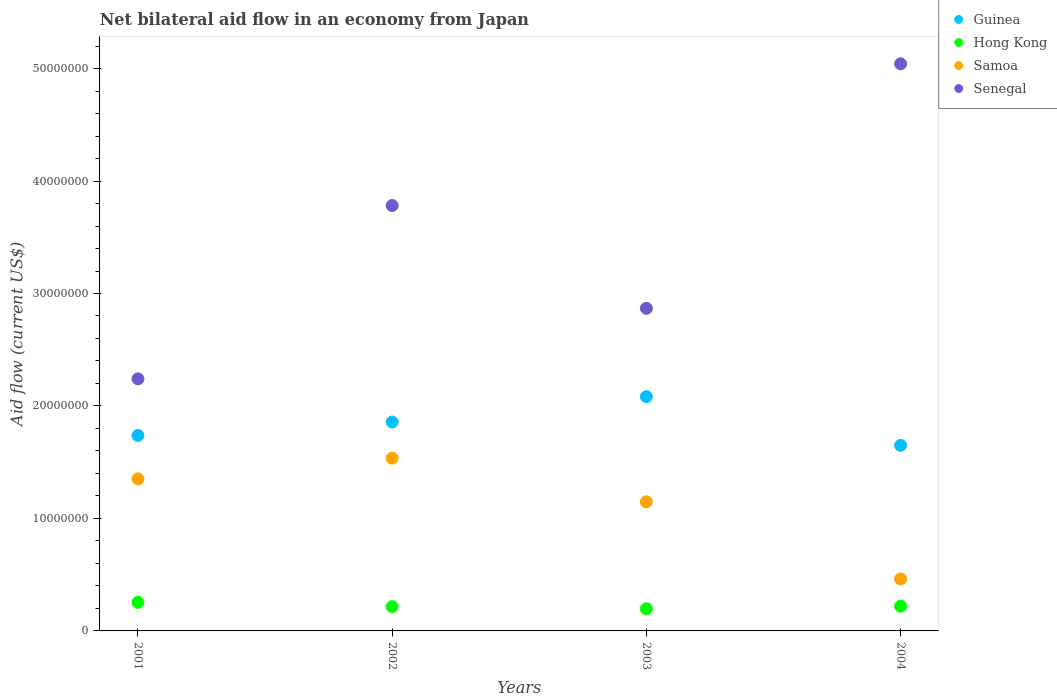What is the net bilateral aid flow in Senegal in 2003?
Provide a short and direct response. 2.87e+07. Across all years, what is the maximum net bilateral aid flow in Samoa?
Make the answer very short. 1.54e+07. Across all years, what is the minimum net bilateral aid flow in Guinea?
Offer a very short reply. 1.65e+07. In which year was the net bilateral aid flow in Hong Kong maximum?
Provide a succinct answer. 2001. What is the total net bilateral aid flow in Guinea in the graph?
Provide a succinct answer. 7.33e+07. What is the difference between the net bilateral aid flow in Hong Kong in 2001 and that in 2004?
Offer a very short reply. 3.40e+05. What is the difference between the net bilateral aid flow in Guinea in 2002 and the net bilateral aid flow in Hong Kong in 2003?
Ensure brevity in your answer.  1.66e+07. What is the average net bilateral aid flow in Senegal per year?
Ensure brevity in your answer.  3.48e+07. In the year 2004, what is the difference between the net bilateral aid flow in Senegal and net bilateral aid flow in Guinea?
Keep it short and to the point. 3.39e+07. In how many years, is the net bilateral aid flow in Samoa greater than 16000000 US$?
Offer a very short reply. 0. What is the ratio of the net bilateral aid flow in Samoa in 2002 to that in 2003?
Make the answer very short. 1.34. Is the difference between the net bilateral aid flow in Senegal in 2003 and 2004 greater than the difference between the net bilateral aid flow in Guinea in 2003 and 2004?
Offer a very short reply. No. What is the difference between the highest and the lowest net bilateral aid flow in Senegal?
Provide a short and direct response. 2.80e+07. Is the sum of the net bilateral aid flow in Hong Kong in 2002 and 2004 greater than the maximum net bilateral aid flow in Guinea across all years?
Make the answer very short. No. Is it the case that in every year, the sum of the net bilateral aid flow in Senegal and net bilateral aid flow in Guinea  is greater than the sum of net bilateral aid flow in Hong Kong and net bilateral aid flow in Samoa?
Your answer should be very brief. Yes. Is it the case that in every year, the sum of the net bilateral aid flow in Senegal and net bilateral aid flow in Samoa  is greater than the net bilateral aid flow in Hong Kong?
Offer a terse response. Yes. Does the net bilateral aid flow in Samoa monotonically increase over the years?
Provide a short and direct response. No. Is the net bilateral aid flow in Guinea strictly greater than the net bilateral aid flow in Samoa over the years?
Offer a terse response. Yes. Is the net bilateral aid flow in Senegal strictly less than the net bilateral aid flow in Samoa over the years?
Provide a succinct answer. No. How many dotlines are there?
Provide a succinct answer. 4. What is the difference between two consecutive major ticks on the Y-axis?
Your answer should be very brief. 1.00e+07. Are the values on the major ticks of Y-axis written in scientific E-notation?
Give a very brief answer. No. Does the graph contain any zero values?
Your response must be concise. No. Where does the legend appear in the graph?
Give a very brief answer. Top right. How many legend labels are there?
Your answer should be compact. 4. What is the title of the graph?
Your answer should be compact. Net bilateral aid flow in an economy from Japan. What is the label or title of the X-axis?
Keep it short and to the point. Years. What is the label or title of the Y-axis?
Provide a succinct answer. Aid flow (current US$). What is the Aid flow (current US$) of Guinea in 2001?
Your answer should be compact. 1.74e+07. What is the Aid flow (current US$) of Hong Kong in 2001?
Keep it short and to the point. 2.54e+06. What is the Aid flow (current US$) in Samoa in 2001?
Give a very brief answer. 1.35e+07. What is the Aid flow (current US$) of Senegal in 2001?
Make the answer very short. 2.24e+07. What is the Aid flow (current US$) of Guinea in 2002?
Your response must be concise. 1.86e+07. What is the Aid flow (current US$) of Hong Kong in 2002?
Offer a very short reply. 2.16e+06. What is the Aid flow (current US$) in Samoa in 2002?
Your answer should be compact. 1.54e+07. What is the Aid flow (current US$) of Senegal in 2002?
Provide a succinct answer. 3.78e+07. What is the Aid flow (current US$) in Guinea in 2003?
Provide a short and direct response. 2.08e+07. What is the Aid flow (current US$) of Hong Kong in 2003?
Your answer should be very brief. 1.97e+06. What is the Aid flow (current US$) in Samoa in 2003?
Ensure brevity in your answer.  1.15e+07. What is the Aid flow (current US$) in Senegal in 2003?
Provide a short and direct response. 2.87e+07. What is the Aid flow (current US$) of Guinea in 2004?
Provide a short and direct response. 1.65e+07. What is the Aid flow (current US$) in Hong Kong in 2004?
Provide a succinct answer. 2.20e+06. What is the Aid flow (current US$) in Samoa in 2004?
Your response must be concise. 4.62e+06. What is the Aid flow (current US$) in Senegal in 2004?
Provide a succinct answer. 5.04e+07. Across all years, what is the maximum Aid flow (current US$) in Guinea?
Your answer should be compact. 2.08e+07. Across all years, what is the maximum Aid flow (current US$) of Hong Kong?
Provide a succinct answer. 2.54e+06. Across all years, what is the maximum Aid flow (current US$) in Samoa?
Your answer should be very brief. 1.54e+07. Across all years, what is the maximum Aid flow (current US$) of Senegal?
Keep it short and to the point. 5.04e+07. Across all years, what is the minimum Aid flow (current US$) in Guinea?
Make the answer very short. 1.65e+07. Across all years, what is the minimum Aid flow (current US$) in Hong Kong?
Your response must be concise. 1.97e+06. Across all years, what is the minimum Aid flow (current US$) of Samoa?
Your answer should be very brief. 4.62e+06. Across all years, what is the minimum Aid flow (current US$) of Senegal?
Ensure brevity in your answer.  2.24e+07. What is the total Aid flow (current US$) of Guinea in the graph?
Your response must be concise. 7.33e+07. What is the total Aid flow (current US$) of Hong Kong in the graph?
Keep it short and to the point. 8.87e+06. What is the total Aid flow (current US$) of Samoa in the graph?
Give a very brief answer. 4.50e+07. What is the total Aid flow (current US$) of Senegal in the graph?
Offer a terse response. 1.39e+08. What is the difference between the Aid flow (current US$) in Guinea in 2001 and that in 2002?
Provide a succinct answer. -1.19e+06. What is the difference between the Aid flow (current US$) in Hong Kong in 2001 and that in 2002?
Offer a terse response. 3.80e+05. What is the difference between the Aid flow (current US$) in Samoa in 2001 and that in 2002?
Your answer should be very brief. -1.84e+06. What is the difference between the Aid flow (current US$) in Senegal in 2001 and that in 2002?
Give a very brief answer. -1.54e+07. What is the difference between the Aid flow (current US$) of Guinea in 2001 and that in 2003?
Your answer should be compact. -3.45e+06. What is the difference between the Aid flow (current US$) in Hong Kong in 2001 and that in 2003?
Provide a succinct answer. 5.70e+05. What is the difference between the Aid flow (current US$) of Samoa in 2001 and that in 2003?
Provide a succinct answer. 2.04e+06. What is the difference between the Aid flow (current US$) in Senegal in 2001 and that in 2003?
Your response must be concise. -6.27e+06. What is the difference between the Aid flow (current US$) in Guinea in 2001 and that in 2004?
Your answer should be very brief. 8.80e+05. What is the difference between the Aid flow (current US$) in Hong Kong in 2001 and that in 2004?
Your answer should be compact. 3.40e+05. What is the difference between the Aid flow (current US$) in Samoa in 2001 and that in 2004?
Offer a terse response. 8.90e+06. What is the difference between the Aid flow (current US$) of Senegal in 2001 and that in 2004?
Offer a very short reply. -2.80e+07. What is the difference between the Aid flow (current US$) of Guinea in 2002 and that in 2003?
Give a very brief answer. -2.26e+06. What is the difference between the Aid flow (current US$) of Hong Kong in 2002 and that in 2003?
Offer a terse response. 1.90e+05. What is the difference between the Aid flow (current US$) in Samoa in 2002 and that in 2003?
Offer a terse response. 3.88e+06. What is the difference between the Aid flow (current US$) of Senegal in 2002 and that in 2003?
Your response must be concise. 9.14e+06. What is the difference between the Aid flow (current US$) of Guinea in 2002 and that in 2004?
Make the answer very short. 2.07e+06. What is the difference between the Aid flow (current US$) in Hong Kong in 2002 and that in 2004?
Provide a succinct answer. -4.00e+04. What is the difference between the Aid flow (current US$) in Samoa in 2002 and that in 2004?
Make the answer very short. 1.07e+07. What is the difference between the Aid flow (current US$) of Senegal in 2002 and that in 2004?
Make the answer very short. -1.26e+07. What is the difference between the Aid flow (current US$) of Guinea in 2003 and that in 2004?
Offer a very short reply. 4.33e+06. What is the difference between the Aid flow (current US$) of Hong Kong in 2003 and that in 2004?
Ensure brevity in your answer.  -2.30e+05. What is the difference between the Aid flow (current US$) in Samoa in 2003 and that in 2004?
Make the answer very short. 6.86e+06. What is the difference between the Aid flow (current US$) of Senegal in 2003 and that in 2004?
Provide a succinct answer. -2.17e+07. What is the difference between the Aid flow (current US$) of Guinea in 2001 and the Aid flow (current US$) of Hong Kong in 2002?
Provide a succinct answer. 1.52e+07. What is the difference between the Aid flow (current US$) in Guinea in 2001 and the Aid flow (current US$) in Samoa in 2002?
Your answer should be very brief. 2.02e+06. What is the difference between the Aid flow (current US$) of Guinea in 2001 and the Aid flow (current US$) of Senegal in 2002?
Provide a short and direct response. -2.04e+07. What is the difference between the Aid flow (current US$) of Hong Kong in 2001 and the Aid flow (current US$) of Samoa in 2002?
Make the answer very short. -1.28e+07. What is the difference between the Aid flow (current US$) of Hong Kong in 2001 and the Aid flow (current US$) of Senegal in 2002?
Your answer should be very brief. -3.53e+07. What is the difference between the Aid flow (current US$) of Samoa in 2001 and the Aid flow (current US$) of Senegal in 2002?
Your answer should be compact. -2.43e+07. What is the difference between the Aid flow (current US$) of Guinea in 2001 and the Aid flow (current US$) of Hong Kong in 2003?
Ensure brevity in your answer.  1.54e+07. What is the difference between the Aid flow (current US$) in Guinea in 2001 and the Aid flow (current US$) in Samoa in 2003?
Your answer should be compact. 5.90e+06. What is the difference between the Aid flow (current US$) of Guinea in 2001 and the Aid flow (current US$) of Senegal in 2003?
Give a very brief answer. -1.13e+07. What is the difference between the Aid flow (current US$) in Hong Kong in 2001 and the Aid flow (current US$) in Samoa in 2003?
Ensure brevity in your answer.  -8.94e+06. What is the difference between the Aid flow (current US$) of Hong Kong in 2001 and the Aid flow (current US$) of Senegal in 2003?
Keep it short and to the point. -2.61e+07. What is the difference between the Aid flow (current US$) in Samoa in 2001 and the Aid flow (current US$) in Senegal in 2003?
Your response must be concise. -1.52e+07. What is the difference between the Aid flow (current US$) of Guinea in 2001 and the Aid flow (current US$) of Hong Kong in 2004?
Give a very brief answer. 1.52e+07. What is the difference between the Aid flow (current US$) in Guinea in 2001 and the Aid flow (current US$) in Samoa in 2004?
Keep it short and to the point. 1.28e+07. What is the difference between the Aid flow (current US$) in Guinea in 2001 and the Aid flow (current US$) in Senegal in 2004?
Provide a short and direct response. -3.30e+07. What is the difference between the Aid flow (current US$) of Hong Kong in 2001 and the Aid flow (current US$) of Samoa in 2004?
Make the answer very short. -2.08e+06. What is the difference between the Aid flow (current US$) of Hong Kong in 2001 and the Aid flow (current US$) of Senegal in 2004?
Provide a succinct answer. -4.79e+07. What is the difference between the Aid flow (current US$) of Samoa in 2001 and the Aid flow (current US$) of Senegal in 2004?
Your answer should be very brief. -3.69e+07. What is the difference between the Aid flow (current US$) of Guinea in 2002 and the Aid flow (current US$) of Hong Kong in 2003?
Your response must be concise. 1.66e+07. What is the difference between the Aid flow (current US$) in Guinea in 2002 and the Aid flow (current US$) in Samoa in 2003?
Give a very brief answer. 7.09e+06. What is the difference between the Aid flow (current US$) in Guinea in 2002 and the Aid flow (current US$) in Senegal in 2003?
Offer a terse response. -1.01e+07. What is the difference between the Aid flow (current US$) of Hong Kong in 2002 and the Aid flow (current US$) of Samoa in 2003?
Give a very brief answer. -9.32e+06. What is the difference between the Aid flow (current US$) in Hong Kong in 2002 and the Aid flow (current US$) in Senegal in 2003?
Ensure brevity in your answer.  -2.65e+07. What is the difference between the Aid flow (current US$) in Samoa in 2002 and the Aid flow (current US$) in Senegal in 2003?
Your response must be concise. -1.33e+07. What is the difference between the Aid flow (current US$) of Guinea in 2002 and the Aid flow (current US$) of Hong Kong in 2004?
Offer a terse response. 1.64e+07. What is the difference between the Aid flow (current US$) in Guinea in 2002 and the Aid flow (current US$) in Samoa in 2004?
Provide a succinct answer. 1.40e+07. What is the difference between the Aid flow (current US$) in Guinea in 2002 and the Aid flow (current US$) in Senegal in 2004?
Provide a succinct answer. -3.18e+07. What is the difference between the Aid flow (current US$) in Hong Kong in 2002 and the Aid flow (current US$) in Samoa in 2004?
Your answer should be very brief. -2.46e+06. What is the difference between the Aid flow (current US$) of Hong Kong in 2002 and the Aid flow (current US$) of Senegal in 2004?
Your answer should be compact. -4.83e+07. What is the difference between the Aid flow (current US$) in Samoa in 2002 and the Aid flow (current US$) in Senegal in 2004?
Provide a succinct answer. -3.51e+07. What is the difference between the Aid flow (current US$) of Guinea in 2003 and the Aid flow (current US$) of Hong Kong in 2004?
Offer a very short reply. 1.86e+07. What is the difference between the Aid flow (current US$) in Guinea in 2003 and the Aid flow (current US$) in Samoa in 2004?
Give a very brief answer. 1.62e+07. What is the difference between the Aid flow (current US$) of Guinea in 2003 and the Aid flow (current US$) of Senegal in 2004?
Give a very brief answer. -2.96e+07. What is the difference between the Aid flow (current US$) of Hong Kong in 2003 and the Aid flow (current US$) of Samoa in 2004?
Your answer should be very brief. -2.65e+06. What is the difference between the Aid flow (current US$) in Hong Kong in 2003 and the Aid flow (current US$) in Senegal in 2004?
Your answer should be very brief. -4.84e+07. What is the difference between the Aid flow (current US$) in Samoa in 2003 and the Aid flow (current US$) in Senegal in 2004?
Your answer should be compact. -3.89e+07. What is the average Aid flow (current US$) in Guinea per year?
Offer a terse response. 1.83e+07. What is the average Aid flow (current US$) in Hong Kong per year?
Ensure brevity in your answer.  2.22e+06. What is the average Aid flow (current US$) of Samoa per year?
Provide a succinct answer. 1.12e+07. What is the average Aid flow (current US$) of Senegal per year?
Give a very brief answer. 3.48e+07. In the year 2001, what is the difference between the Aid flow (current US$) in Guinea and Aid flow (current US$) in Hong Kong?
Provide a short and direct response. 1.48e+07. In the year 2001, what is the difference between the Aid flow (current US$) of Guinea and Aid flow (current US$) of Samoa?
Make the answer very short. 3.86e+06. In the year 2001, what is the difference between the Aid flow (current US$) in Guinea and Aid flow (current US$) in Senegal?
Give a very brief answer. -5.03e+06. In the year 2001, what is the difference between the Aid flow (current US$) in Hong Kong and Aid flow (current US$) in Samoa?
Ensure brevity in your answer.  -1.10e+07. In the year 2001, what is the difference between the Aid flow (current US$) in Hong Kong and Aid flow (current US$) in Senegal?
Provide a succinct answer. -1.99e+07. In the year 2001, what is the difference between the Aid flow (current US$) of Samoa and Aid flow (current US$) of Senegal?
Provide a succinct answer. -8.89e+06. In the year 2002, what is the difference between the Aid flow (current US$) in Guinea and Aid flow (current US$) in Hong Kong?
Make the answer very short. 1.64e+07. In the year 2002, what is the difference between the Aid flow (current US$) of Guinea and Aid flow (current US$) of Samoa?
Offer a terse response. 3.21e+06. In the year 2002, what is the difference between the Aid flow (current US$) in Guinea and Aid flow (current US$) in Senegal?
Your answer should be compact. -1.92e+07. In the year 2002, what is the difference between the Aid flow (current US$) of Hong Kong and Aid flow (current US$) of Samoa?
Your answer should be very brief. -1.32e+07. In the year 2002, what is the difference between the Aid flow (current US$) of Hong Kong and Aid flow (current US$) of Senegal?
Offer a very short reply. -3.57e+07. In the year 2002, what is the difference between the Aid flow (current US$) of Samoa and Aid flow (current US$) of Senegal?
Make the answer very short. -2.25e+07. In the year 2003, what is the difference between the Aid flow (current US$) in Guinea and Aid flow (current US$) in Hong Kong?
Your response must be concise. 1.89e+07. In the year 2003, what is the difference between the Aid flow (current US$) in Guinea and Aid flow (current US$) in Samoa?
Offer a terse response. 9.35e+06. In the year 2003, what is the difference between the Aid flow (current US$) in Guinea and Aid flow (current US$) in Senegal?
Make the answer very short. -7.85e+06. In the year 2003, what is the difference between the Aid flow (current US$) in Hong Kong and Aid flow (current US$) in Samoa?
Make the answer very short. -9.51e+06. In the year 2003, what is the difference between the Aid flow (current US$) in Hong Kong and Aid flow (current US$) in Senegal?
Your answer should be compact. -2.67e+07. In the year 2003, what is the difference between the Aid flow (current US$) in Samoa and Aid flow (current US$) in Senegal?
Your answer should be compact. -1.72e+07. In the year 2004, what is the difference between the Aid flow (current US$) of Guinea and Aid flow (current US$) of Hong Kong?
Your response must be concise. 1.43e+07. In the year 2004, what is the difference between the Aid flow (current US$) of Guinea and Aid flow (current US$) of Samoa?
Provide a succinct answer. 1.19e+07. In the year 2004, what is the difference between the Aid flow (current US$) in Guinea and Aid flow (current US$) in Senegal?
Your answer should be compact. -3.39e+07. In the year 2004, what is the difference between the Aid flow (current US$) in Hong Kong and Aid flow (current US$) in Samoa?
Offer a very short reply. -2.42e+06. In the year 2004, what is the difference between the Aid flow (current US$) of Hong Kong and Aid flow (current US$) of Senegal?
Ensure brevity in your answer.  -4.82e+07. In the year 2004, what is the difference between the Aid flow (current US$) of Samoa and Aid flow (current US$) of Senegal?
Provide a short and direct response. -4.58e+07. What is the ratio of the Aid flow (current US$) of Guinea in 2001 to that in 2002?
Your answer should be very brief. 0.94. What is the ratio of the Aid flow (current US$) of Hong Kong in 2001 to that in 2002?
Offer a terse response. 1.18. What is the ratio of the Aid flow (current US$) in Samoa in 2001 to that in 2002?
Make the answer very short. 0.88. What is the ratio of the Aid flow (current US$) of Senegal in 2001 to that in 2002?
Offer a terse response. 0.59. What is the ratio of the Aid flow (current US$) of Guinea in 2001 to that in 2003?
Offer a very short reply. 0.83. What is the ratio of the Aid flow (current US$) in Hong Kong in 2001 to that in 2003?
Give a very brief answer. 1.29. What is the ratio of the Aid flow (current US$) in Samoa in 2001 to that in 2003?
Ensure brevity in your answer.  1.18. What is the ratio of the Aid flow (current US$) in Senegal in 2001 to that in 2003?
Provide a short and direct response. 0.78. What is the ratio of the Aid flow (current US$) of Guinea in 2001 to that in 2004?
Your answer should be compact. 1.05. What is the ratio of the Aid flow (current US$) in Hong Kong in 2001 to that in 2004?
Offer a very short reply. 1.15. What is the ratio of the Aid flow (current US$) in Samoa in 2001 to that in 2004?
Make the answer very short. 2.93. What is the ratio of the Aid flow (current US$) in Senegal in 2001 to that in 2004?
Offer a very short reply. 0.44. What is the ratio of the Aid flow (current US$) of Guinea in 2002 to that in 2003?
Offer a very short reply. 0.89. What is the ratio of the Aid flow (current US$) of Hong Kong in 2002 to that in 2003?
Offer a terse response. 1.1. What is the ratio of the Aid flow (current US$) of Samoa in 2002 to that in 2003?
Your answer should be very brief. 1.34. What is the ratio of the Aid flow (current US$) in Senegal in 2002 to that in 2003?
Offer a very short reply. 1.32. What is the ratio of the Aid flow (current US$) of Guinea in 2002 to that in 2004?
Provide a short and direct response. 1.13. What is the ratio of the Aid flow (current US$) of Hong Kong in 2002 to that in 2004?
Your answer should be compact. 0.98. What is the ratio of the Aid flow (current US$) in Samoa in 2002 to that in 2004?
Provide a short and direct response. 3.32. What is the ratio of the Aid flow (current US$) of Senegal in 2002 to that in 2004?
Provide a succinct answer. 0.75. What is the ratio of the Aid flow (current US$) in Guinea in 2003 to that in 2004?
Give a very brief answer. 1.26. What is the ratio of the Aid flow (current US$) of Hong Kong in 2003 to that in 2004?
Provide a succinct answer. 0.9. What is the ratio of the Aid flow (current US$) of Samoa in 2003 to that in 2004?
Offer a terse response. 2.48. What is the ratio of the Aid flow (current US$) of Senegal in 2003 to that in 2004?
Make the answer very short. 0.57. What is the difference between the highest and the second highest Aid flow (current US$) in Guinea?
Your response must be concise. 2.26e+06. What is the difference between the highest and the second highest Aid flow (current US$) in Hong Kong?
Make the answer very short. 3.40e+05. What is the difference between the highest and the second highest Aid flow (current US$) of Samoa?
Give a very brief answer. 1.84e+06. What is the difference between the highest and the second highest Aid flow (current US$) of Senegal?
Give a very brief answer. 1.26e+07. What is the difference between the highest and the lowest Aid flow (current US$) of Guinea?
Keep it short and to the point. 4.33e+06. What is the difference between the highest and the lowest Aid flow (current US$) in Hong Kong?
Make the answer very short. 5.70e+05. What is the difference between the highest and the lowest Aid flow (current US$) in Samoa?
Make the answer very short. 1.07e+07. What is the difference between the highest and the lowest Aid flow (current US$) of Senegal?
Give a very brief answer. 2.80e+07. 